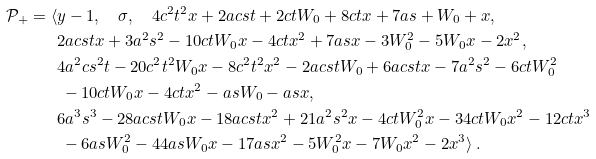Convert formula to latex. <formula><loc_0><loc_0><loc_500><loc_500>\mathcal { P } _ { + } = \langle & y - 1 , \quad \sigma , \quad 4 c ^ { 2 } t ^ { 2 } x + 2 a c s t + 2 c t W _ { 0 } + 8 c t x + 7 a s + W _ { 0 } + x , \\ & 2 a c s t x + 3 a ^ { 2 } s ^ { 2 } - 1 0 c t W _ { 0 } x - 4 c t x ^ { 2 } + 7 a s x - 3 W _ { 0 } ^ { 2 } - 5 W _ { 0 } x - 2 x ^ { 2 } , \\ & 4 a ^ { 2 } c s ^ { 2 } t - 2 0 c ^ { 2 } t ^ { 2 } W _ { 0 } x - 8 c ^ { 2 } t ^ { 2 } x ^ { 2 } - 2 a c s t W _ { 0 } + 6 a c s t x - 7 a ^ { 2 } s ^ { 2 } - 6 c t W _ { 0 } ^ { 2 } \\ & \ - 1 0 c t W _ { 0 } x - 4 c t x ^ { 2 } - a s W _ { 0 } - a s x , \\ & 6 a ^ { 3 } s ^ { 3 } - 2 8 a c s t W _ { 0 } x - 1 8 a c s t x ^ { 2 } + 2 1 a ^ { 2 } s ^ { 2 } x - 4 c t W _ { 0 } ^ { 2 } x - 3 4 c t W _ { 0 } x ^ { 2 } - 1 2 c t x ^ { 3 } \\ & \ - 6 a s W _ { 0 } ^ { 2 } - 4 4 a s W _ { 0 } x - 1 7 a s x ^ { 2 } - 5 W _ { 0 } ^ { 2 } x - 7 W _ { 0 } x ^ { 2 } - 2 x ^ { 3 } \rangle \ .</formula> 